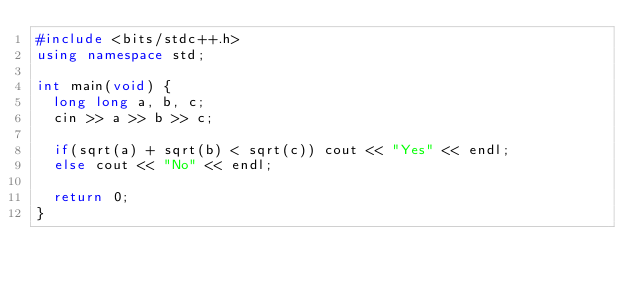Convert code to text. <code><loc_0><loc_0><loc_500><loc_500><_C++_>#include <bits/stdc++.h>
using namespace std;

int main(void) {
  long long a, b, c;
  cin >> a >> b >> c;

  if(sqrt(a) + sqrt(b) < sqrt(c)) cout << "Yes" << endl;
  else cout << "No" << endl;
  
  return 0;
}</code> 